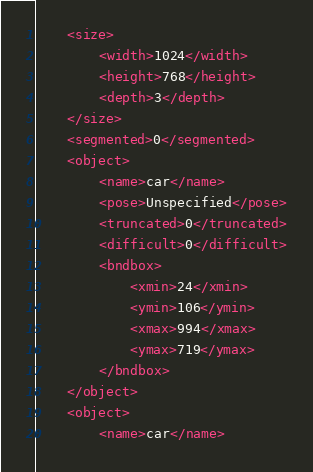Convert code to text. <code><loc_0><loc_0><loc_500><loc_500><_XML_>	<size>
		<width>1024</width>
		<height>768</height>
		<depth>3</depth>
	</size>
	<segmented>0</segmented>
	<object>
		<name>car</name>
		<pose>Unspecified</pose>
		<truncated>0</truncated>
		<difficult>0</difficult>
		<bndbox>
			<xmin>24</xmin>
			<ymin>106</ymin>
			<xmax>994</xmax>
			<ymax>719</ymax>
		</bndbox>
	</object>
	<object>
		<name>car</name></code> 